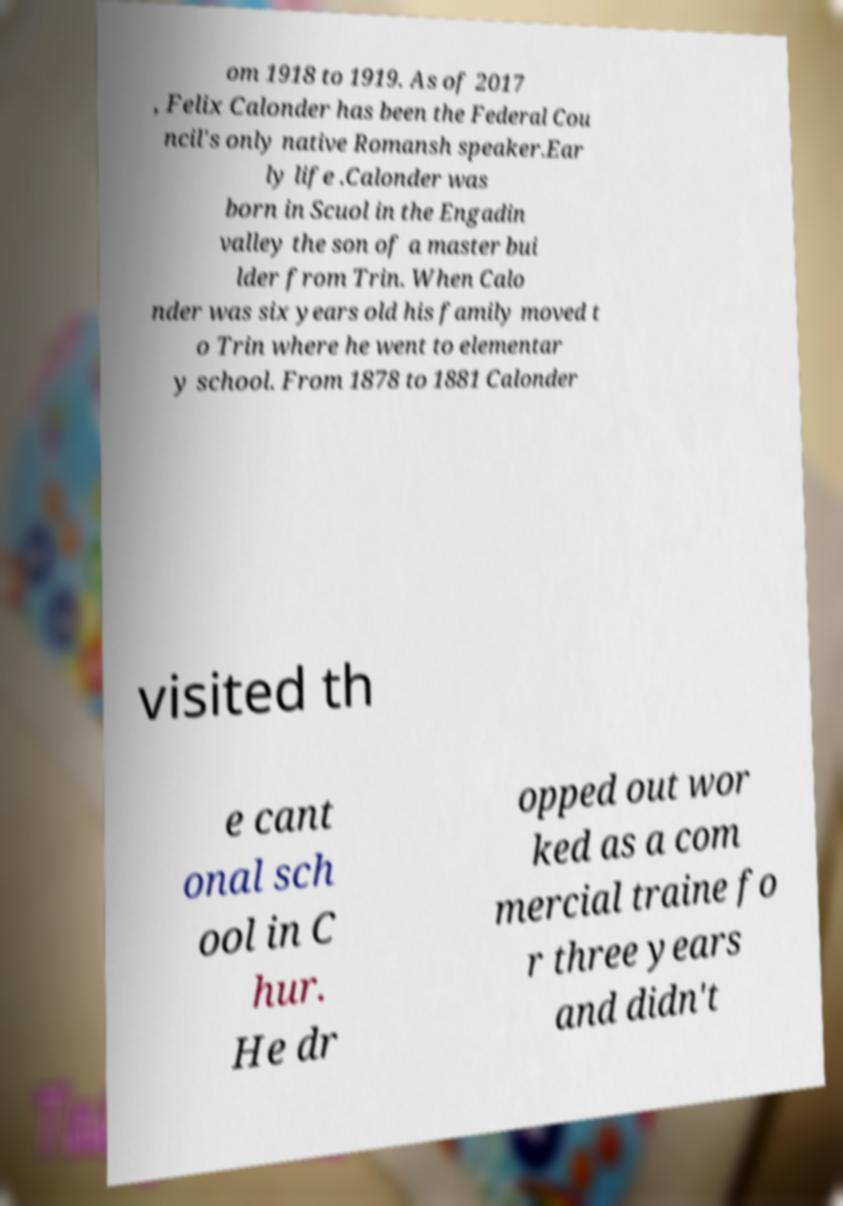For documentation purposes, I need the text within this image transcribed. Could you provide that? om 1918 to 1919. As of 2017 , Felix Calonder has been the Federal Cou ncil's only native Romansh speaker.Ear ly life .Calonder was born in Scuol in the Engadin valley the son of a master bui lder from Trin. When Calo nder was six years old his family moved t o Trin where he went to elementar y school. From 1878 to 1881 Calonder visited th e cant onal sch ool in C hur. He dr opped out wor ked as a com mercial traine fo r three years and didn't 